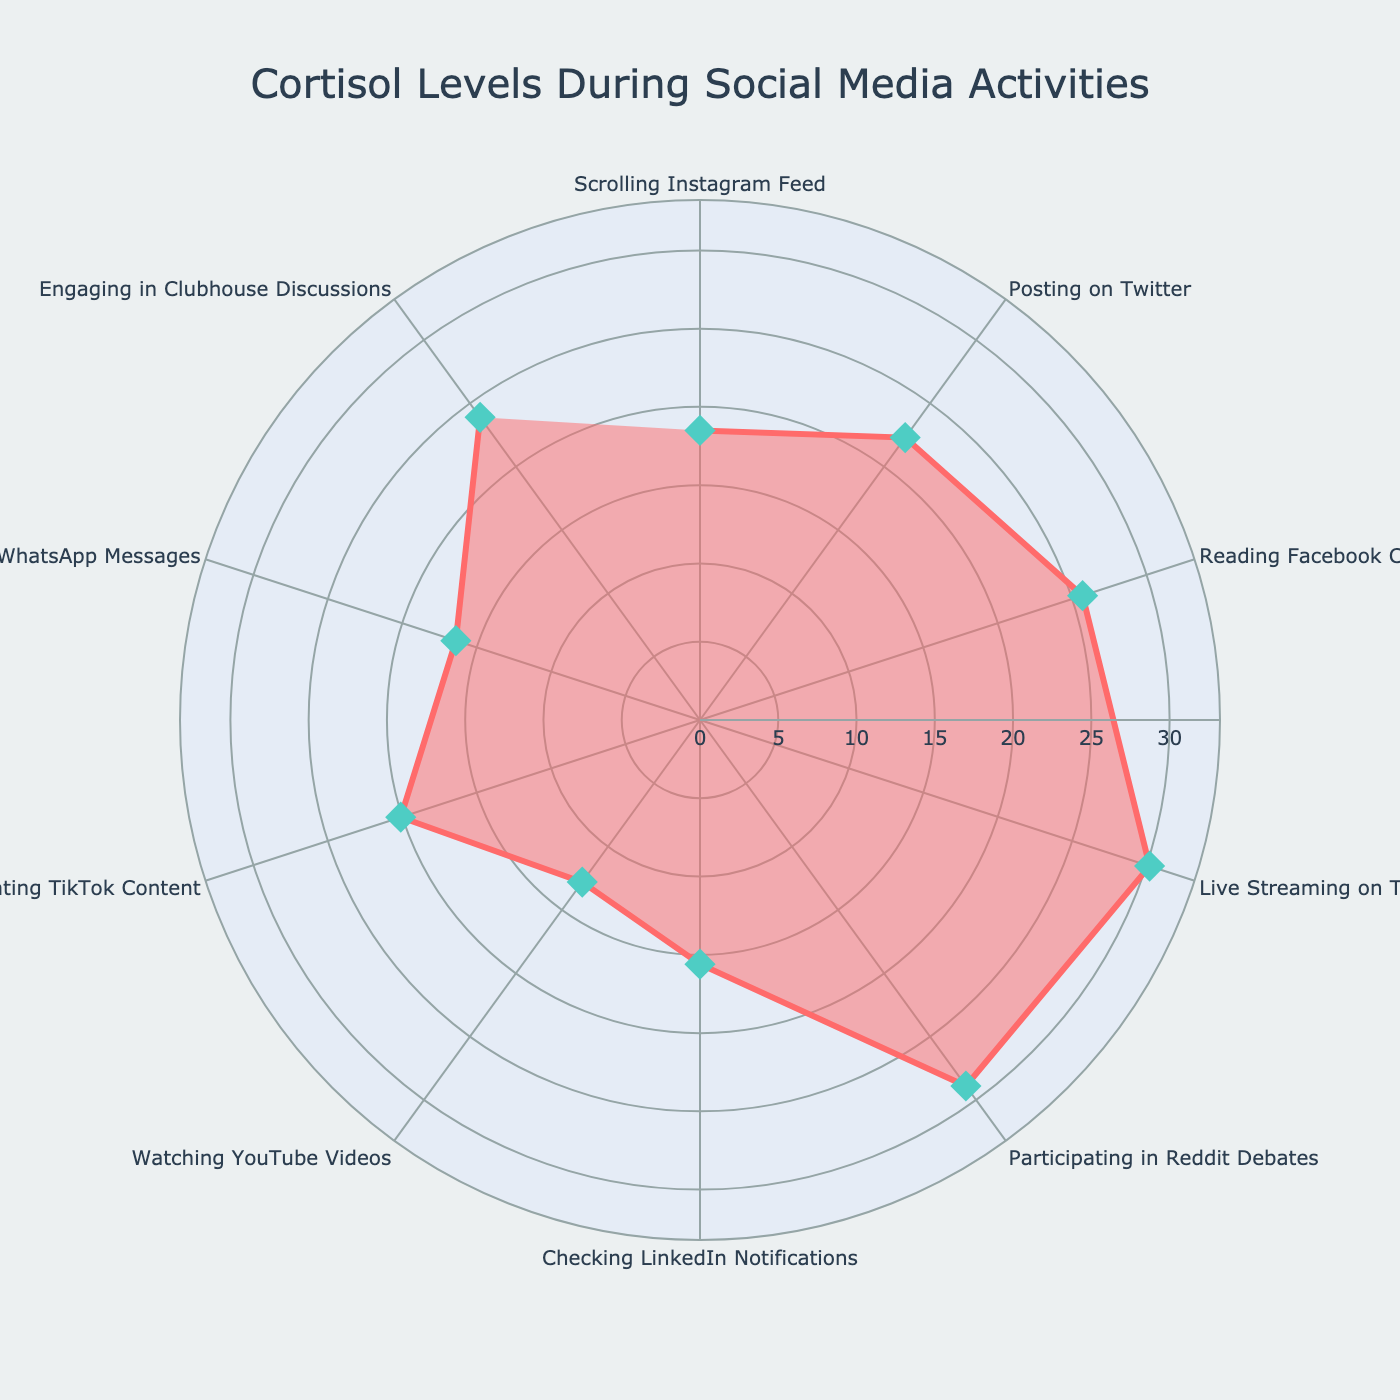How many social media activities are represented in the polar chart? Count the number of activities listed around the polar chart. There are 10 distinct activities.
Answer: 10 Which social media activity is associated with the highest cortisol level? Look for the activity that is plotted the furthest from the center. "Live Streaming on Twitch" has the highest cortisol level of 30.2 nmol/L.
Answer: Live Streaming on Twitch What is the range of cortisol levels depicted in the chart? Identify the maximum and minimum cortisol levels from the chart. The maximum is 30.2 nmol/L, and the minimum is 12.8 nmol/L. The range is 30.2 - 12.8 = 17.4 nmol/L.
Answer: 17.4 nmol/L Which two activities have cortisol levels closest to each other? Compare the distances of the plotted points from the center. "Creating TikTok Content" (20.1 nmol/L) and "Posting on Twitter" (22.3 nmol/L) are closest with a difference of 2.2 nmol/L.
Answer: Creating TikTok Content and Posting on Twitter What is the average cortisol level for all activities? Sum all the cortisol levels and divide by the number of activities: (18.5 + 22.3 + 25.7 + 30.2 + 28.9 + 15.6 + 12.8 + 20.1 + 16.4 + 23.9) / 10 = 21.44 nmol/L.
Answer: 21.44 nmol/L How does engaging in Clubhouse discussions compare to checking LinkedIn notifications in terms of cortisol levels? Determine the difference between the two cortisol levels: 23.9 nmol/L - 15.6 nmol/L = 8.3 nmol/L. Engaging in Clubhouse discussions results in a higher cortisol level by 8.3 nmol/L.
Answer: Engaging in Clubhouse discussions leads to a higher cortisol level by 8.3 nmol/L Which activity falls on the radial axis passing through the maximum cortisol level? Identify the activity plotted at the maximum radial distance and note the corresponding axis. "Live Streaming on Twitch" falls on this axis.
Answer: Live Streaming on Twitch In which quadrant of the polar chart is "Watching YouTube Videos" located? Divide the chart into quadrants based on directions (e.g., top-right, top-left). "Watching YouTube Videos" is in the top-left quadrant of the chart.
Answer: Top-left If you were to combine the cortisol levels of Posting on Twitter and Reading Facebook Comments, what would be the total? Add the cortisol levels of the two activities: 22.3 nmol/L + 25.7 nmol/L = 48 nmol/L.
Answer: 48 nmol/L What visual element indicates the highest cortisol level activity? Identify the stylistic choice such as fill, color, or size that distinguishes the highest value. "Live Streaming on Twitch" is marked by being the farthest from the center and likely larger point size.
Answer: Distance from center and size 